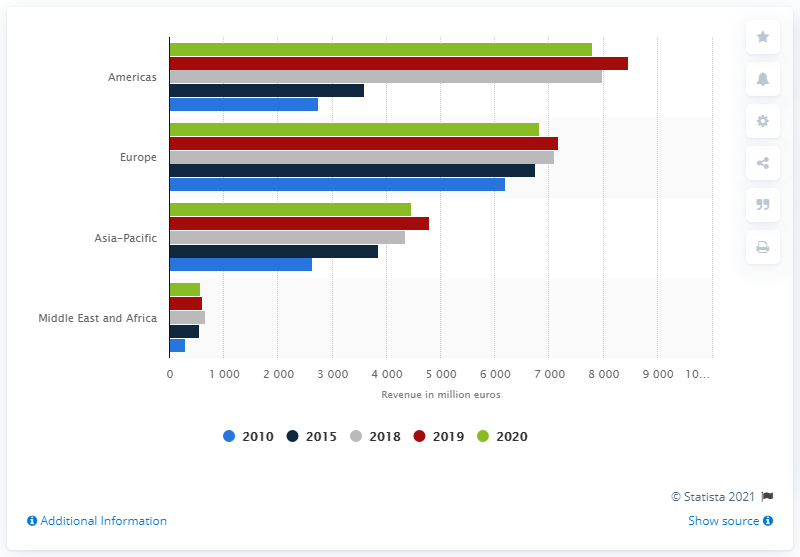Outline some significant characteristics in this image. In 2020, the revenue of Air Liquide's gas and services division in the Americas was 7,799. 